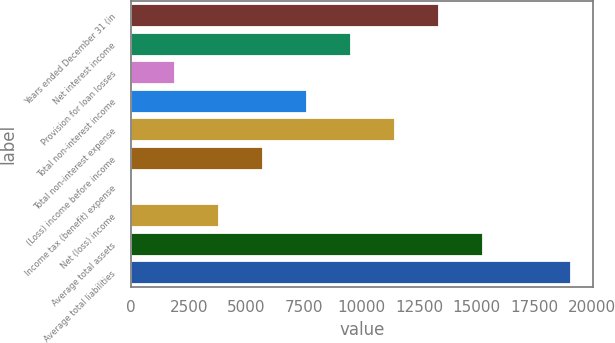Convert chart to OTSL. <chart><loc_0><loc_0><loc_500><loc_500><bar_chart><fcel>Years ended December 31 (in<fcel>Net interest income<fcel>Provision for loan losses<fcel>Total non-interest income<fcel>Total non-interest expense<fcel>(Loss) income before income<fcel>Income tax (benefit) expense<fcel>Net (loss) income<fcel>Average total assets<fcel>Average total liabilities<nl><fcel>13379.5<fcel>9559.75<fcel>1920.19<fcel>7649.86<fcel>11469.6<fcel>5739.97<fcel>10.3<fcel>3830.08<fcel>15289.4<fcel>19109.2<nl></chart> 